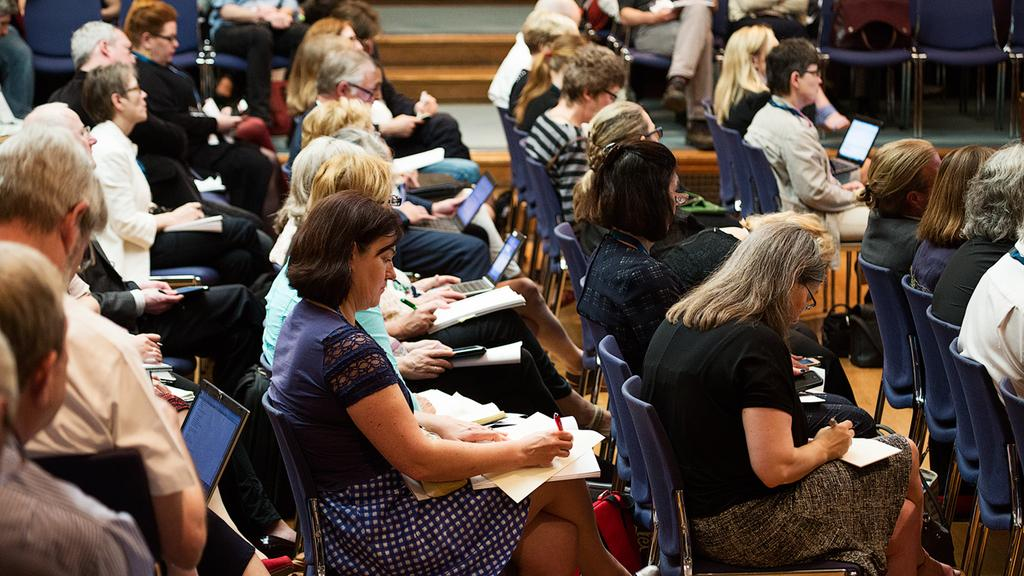What are the people in the image doing? There is a group of people sitting in the image, holding pens, papers, and laptops. What objects are the people holding in their hands? The people are holding pens, papers, and laptops. What can be seen in the background of the image? There are blue chairs and stairs in the background of the image. What type of trucks can be seen driving up the stairs in the image? There are no trucks present in the image; it features a group of people sitting and holding various objects. 